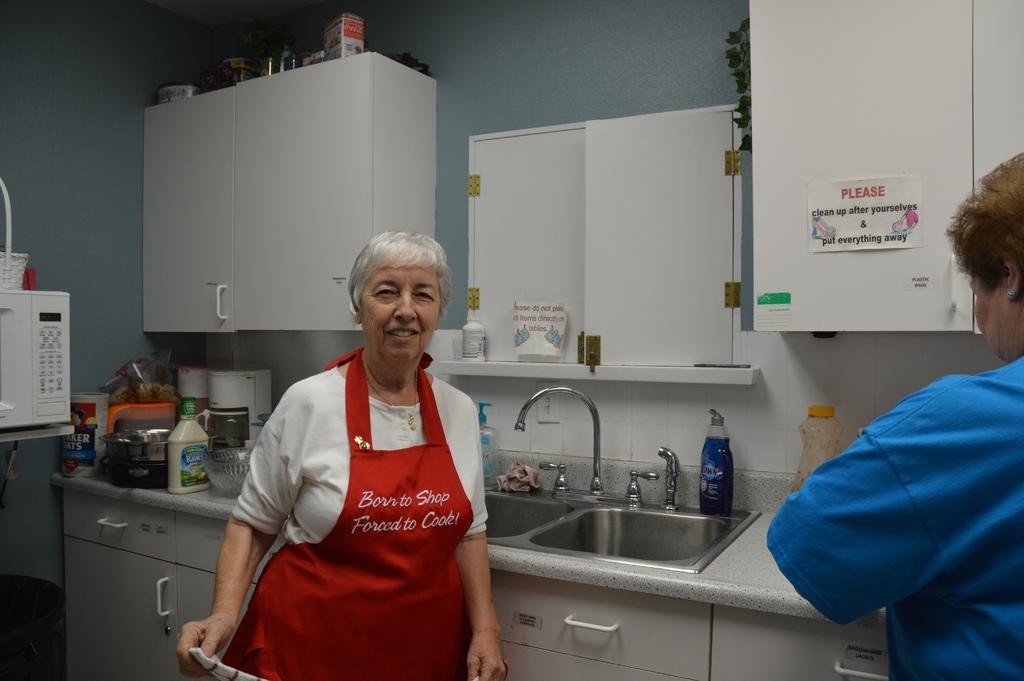<image>
Share a concise interpretation of the image provided. a woman in a kitchen wearing an apron saying Born to Shop Forced to Cook! 